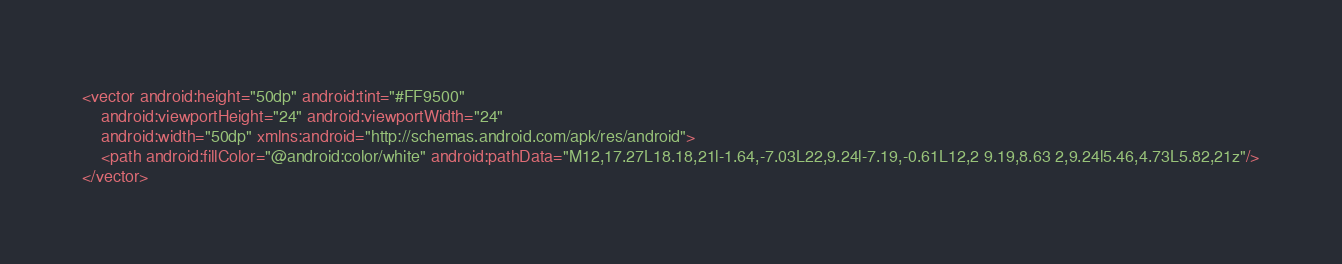Convert code to text. <code><loc_0><loc_0><loc_500><loc_500><_XML_><vector android:height="50dp" android:tint="#FF9500"
    android:viewportHeight="24" android:viewportWidth="24"
    android:width="50dp" xmlns:android="http://schemas.android.com/apk/res/android">
    <path android:fillColor="@android:color/white" android:pathData="M12,17.27L18.18,21l-1.64,-7.03L22,9.24l-7.19,-0.61L12,2 9.19,8.63 2,9.24l5.46,4.73L5.82,21z"/>
</vector>
</code> 